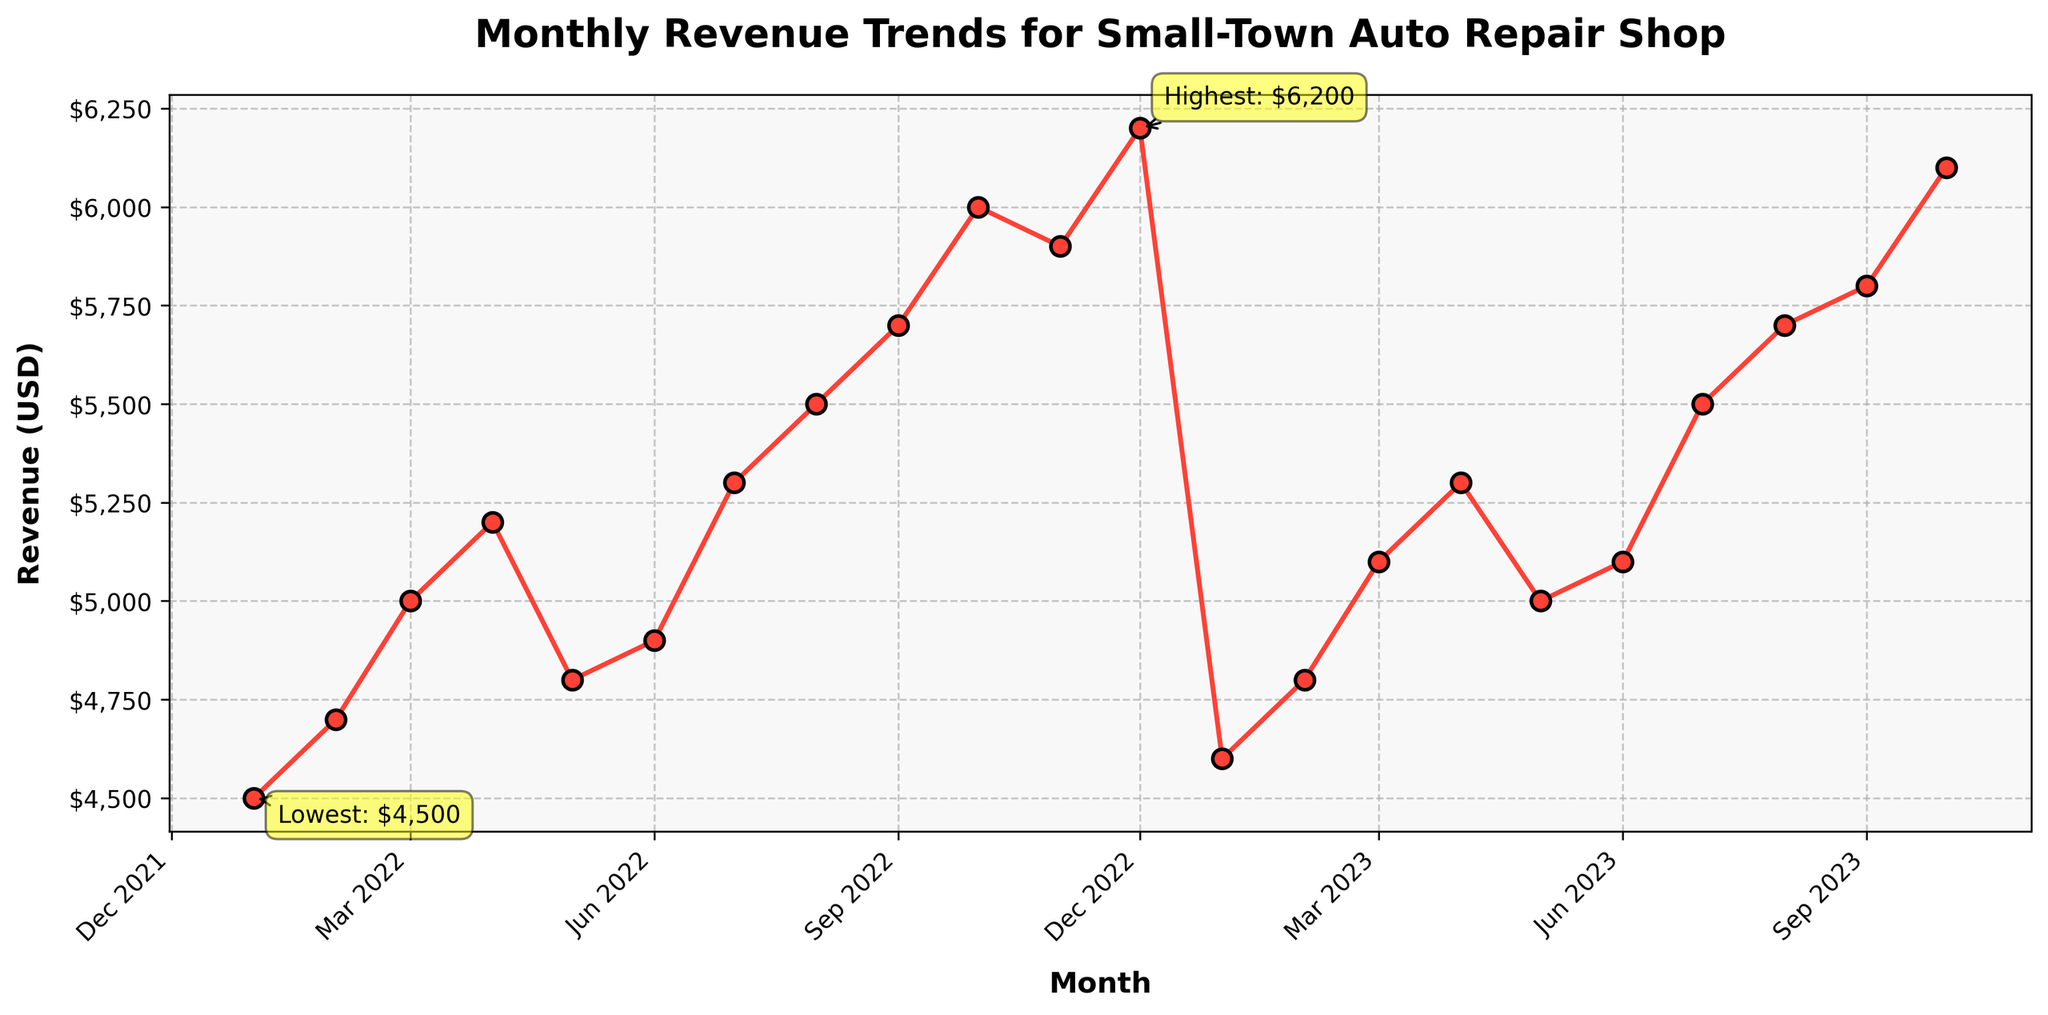what is the title of the plot? The title is usually displayed prominently at the top of the plot and is meant to describe what the plot is about. The title here is "Monthly Revenue Trends for Small-Town Auto Repair Shop".
Answer: Monthly Revenue Trends for Small-Town Auto Repair Shop what month has the highest revenue? The highest point on the plot is marked with a specific annotation. By finding this annotation, you can identify the month with the highest revenue.
Answer: December 2022 what month has the lowest revenue? The lowest point on the plot is also marked with a specific annotation. By locating this annotation, you can identify the month with the lowest revenue.
Answer: January 2022 what is the revenue difference between December 2022 and January 2022? From the plot, the revenue in December 2022 is $6200, and in January 2022, it is $4500. Subtract the January revenue from the December revenue to get the difference. 6200 - 4500 = 1700.
Answer: 1700 USD what overall trend can be seen from January 2022 to October 2023? By observing the plot from left to right, you can see the general direction the plot is moving in. The plot shows an overall upward trend from January 2022 to October 2023.
Answer: Upward trend which months show a revenue of over $6000? Identify the months where the revenue exceeds $6000 by looking at the y-axis and corresponding data points above this threshold. These months are December 2022, October 2023, and January 2023.
Answer: December 2022, October 2023 how would you describe the revenue change between July 2022 and August 2023? Comparing the data points for July 2022 ($5300) and August 2023 ($5700), we see an increase. By calculating the difference, we get 5700 - 5300 = 400. The revenue increased by 400 USD.
Answer: Increase by 400 USD what is the average revenue of the first quarter of 2022? Add the monthly revenues for January, February, and March 2022, then divide by the number of months. (4500 + 4700 + 5000) / 3 = 4875.
Answer: 4875 USD are there any months where the revenue stayed the same from one month to the next? Scan the continuous time series for any repeated revenue values month-on-month. All revenues are unique, so there are no consecutive months with the same revenue.
Answer: No 